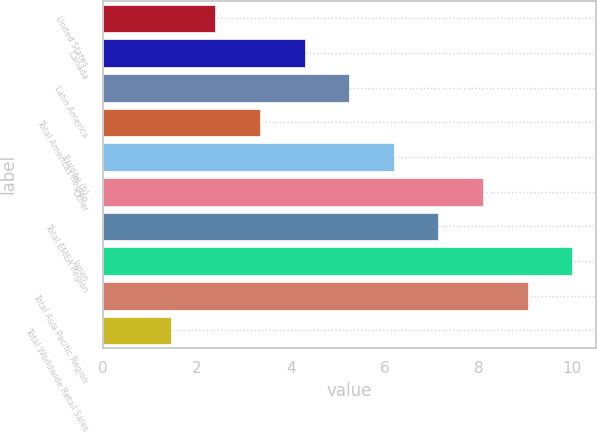Convert chart to OTSL. <chart><loc_0><loc_0><loc_500><loc_500><bar_chart><fcel>United States<fcel>Canada<fcel>Latin America<fcel>Total Americas Region<fcel>Europe (b)<fcel>Other<fcel>Total EMEA Region<fcel>Japan<fcel>Total Asia Pacific Region<fcel>Total Worldwide Retail Sales<nl><fcel>2.4<fcel>4.3<fcel>5.25<fcel>3.35<fcel>6.2<fcel>8.1<fcel>7.15<fcel>10<fcel>9.05<fcel>1.45<nl></chart> 